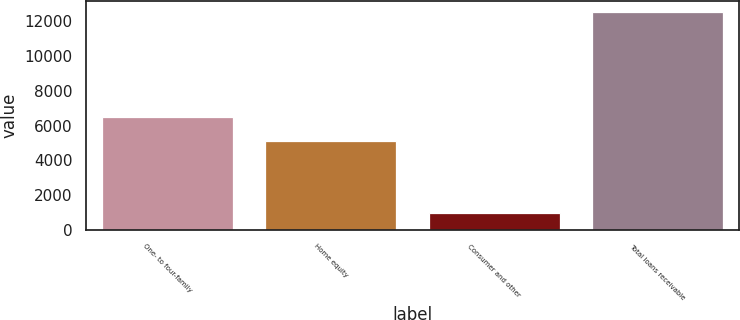<chart> <loc_0><loc_0><loc_500><loc_500><bar_chart><fcel>One- to four-family<fcel>Home equity<fcel>Consumer and other<fcel>Total loans receivable<nl><fcel>6488.7<fcel>5107.8<fcel>968.8<fcel>12565.3<nl></chart> 